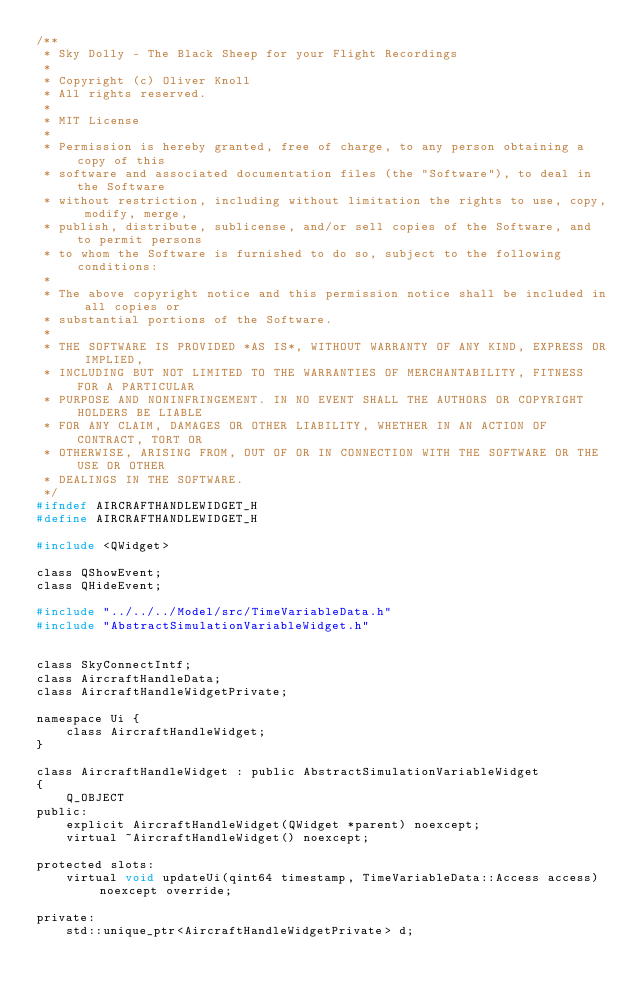Convert code to text. <code><loc_0><loc_0><loc_500><loc_500><_C_>/**
 * Sky Dolly - The Black Sheep for your Flight Recordings
 *
 * Copyright (c) Oliver Knoll
 * All rights reserved.
 *
 * MIT License
 *
 * Permission is hereby granted, free of charge, to any person obtaining a copy of this
 * software and associated documentation files (the "Software"), to deal in the Software
 * without restriction, including without limitation the rights to use, copy, modify, merge,
 * publish, distribute, sublicense, and/or sell copies of the Software, and to permit persons
 * to whom the Software is furnished to do so, subject to the following conditions:
 *
 * The above copyright notice and this permission notice shall be included in all copies or
 * substantial portions of the Software.
 *
 * THE SOFTWARE IS PROVIDED *AS IS*, WITHOUT WARRANTY OF ANY KIND, EXPRESS OR IMPLIED,
 * INCLUDING BUT NOT LIMITED TO THE WARRANTIES OF MERCHANTABILITY, FITNESS FOR A PARTICULAR
 * PURPOSE AND NONINFRINGEMENT. IN NO EVENT SHALL THE AUTHORS OR COPYRIGHT HOLDERS BE LIABLE
 * FOR ANY CLAIM, DAMAGES OR OTHER LIABILITY, WHETHER IN AN ACTION OF CONTRACT, TORT OR
 * OTHERWISE, ARISING FROM, OUT OF OR IN CONNECTION WITH THE SOFTWARE OR THE USE OR OTHER
 * DEALINGS IN THE SOFTWARE.
 */
#ifndef AIRCRAFTHANDLEWIDGET_H
#define AIRCRAFTHANDLEWIDGET_H

#include <QWidget>

class QShowEvent;
class QHideEvent;

#include "../../../Model/src/TimeVariableData.h"
#include "AbstractSimulationVariableWidget.h"


class SkyConnectIntf;
class AircraftHandleData;
class AircraftHandleWidgetPrivate;

namespace Ui {
    class AircraftHandleWidget;
}

class AircraftHandleWidget : public AbstractSimulationVariableWidget
{
    Q_OBJECT
public:
    explicit AircraftHandleWidget(QWidget *parent) noexcept;
    virtual ~AircraftHandleWidget() noexcept;

protected slots:
    virtual void updateUi(qint64 timestamp, TimeVariableData::Access access) noexcept override;

private:
    std::unique_ptr<AircraftHandleWidgetPrivate> d;</code> 